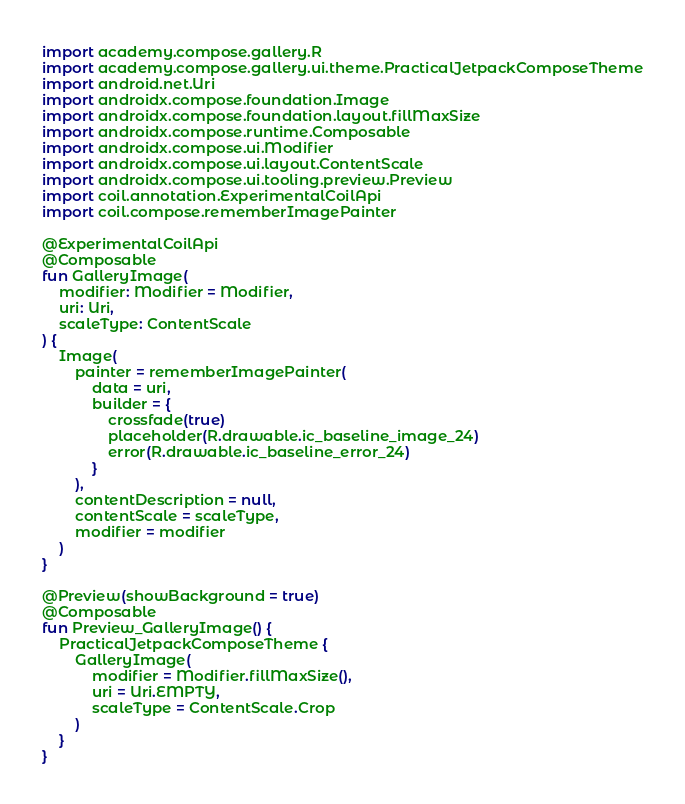<code> <loc_0><loc_0><loc_500><loc_500><_Kotlin_>import academy.compose.gallery.R
import academy.compose.gallery.ui.theme.PracticalJetpackComposeTheme
import android.net.Uri
import androidx.compose.foundation.Image
import androidx.compose.foundation.layout.fillMaxSize
import androidx.compose.runtime.Composable
import androidx.compose.ui.Modifier
import androidx.compose.ui.layout.ContentScale
import androidx.compose.ui.tooling.preview.Preview
import coil.annotation.ExperimentalCoilApi
import coil.compose.rememberImagePainter

@ExperimentalCoilApi
@Composable
fun GalleryImage(
    modifier: Modifier = Modifier,
    uri: Uri,
    scaleType: ContentScale
) {
    Image(
        painter = rememberImagePainter(
            data = uri,
            builder = {
                crossfade(true)
                placeholder(R.drawable.ic_baseline_image_24)
                error(R.drawable.ic_baseline_error_24)
            }
        ),
        contentDescription = null,
        contentScale = scaleType,
        modifier = modifier
    )
}

@Preview(showBackground = true)
@Composable
fun Preview_GalleryImage() {
    PracticalJetpackComposeTheme {
        GalleryImage(
            modifier = Modifier.fillMaxSize(),
            uri = Uri.EMPTY,
            scaleType = ContentScale.Crop
        )
    }
}</code> 